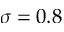<formula> <loc_0><loc_0><loc_500><loc_500>\sigma = 0 . 8</formula> 